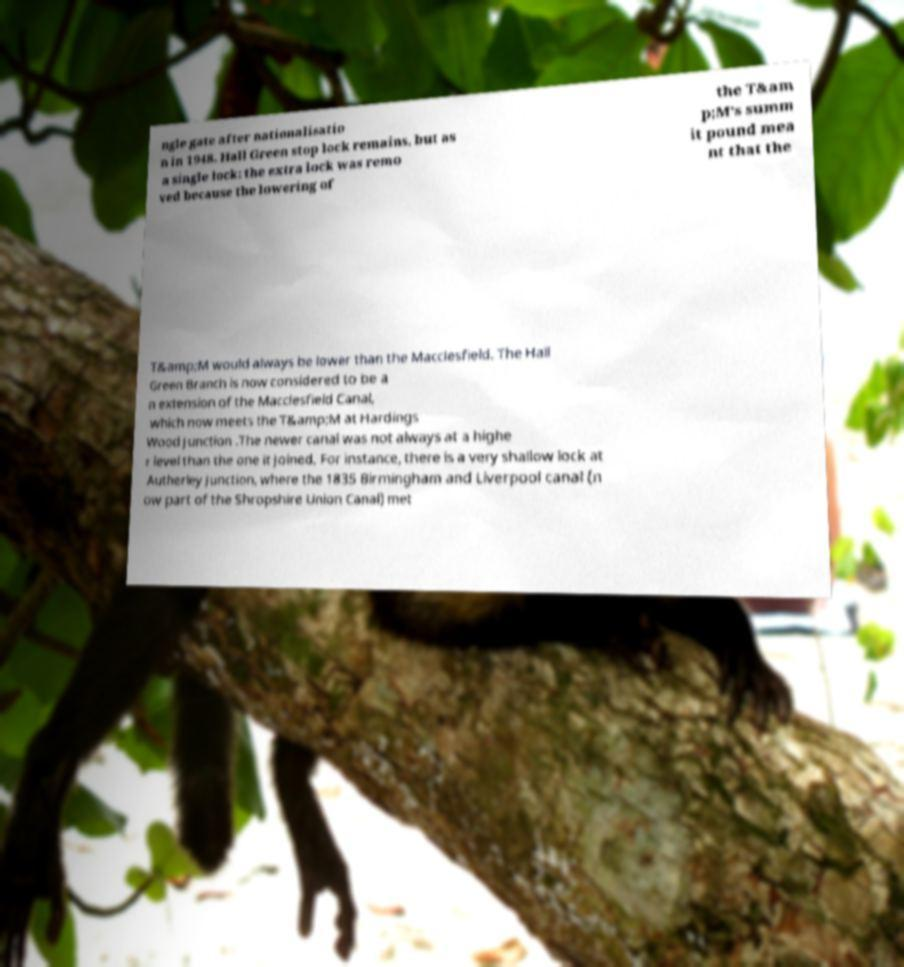For documentation purposes, I need the text within this image transcribed. Could you provide that? ngle gate after nationalisatio n in 1948. Hall Green stop lock remains, but as a single lock: the extra lock was remo ved because the lowering of the T&am p;M's summ it pound mea nt that the T&amp;M would always be lower than the Macclesfield. The Hall Green Branch is now considered to be a n extension of the Macclesfield Canal, which now meets the T&amp;M at Hardings Wood Junction .The newer canal was not always at a highe r level than the one it joined. For instance, there is a very shallow lock at Autherley Junction, where the 1835 Birmingham and Liverpool canal (n ow part of the Shropshire Union Canal) met 